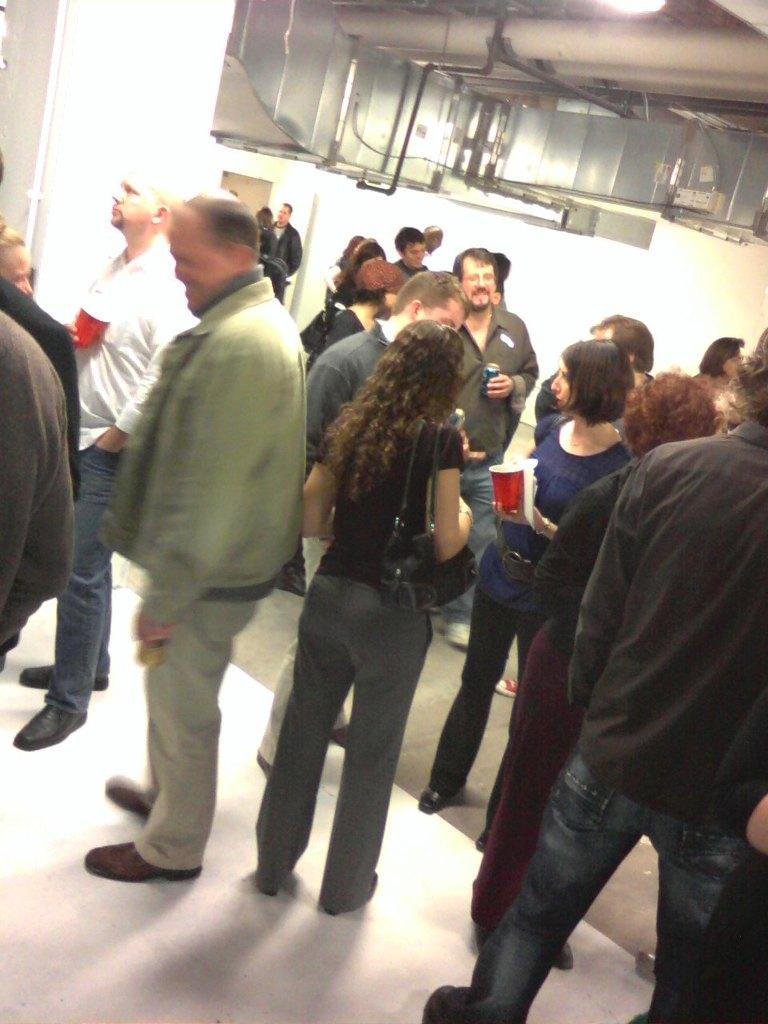What type of structure can be seen in the image? There is a pillar and a wall in the image. What else is present in the image besides the structures? There are objects and people in the image. What are some people doing in the image? Some people are standing, and some are holding objects. What can be seen at the bottom of the image? The floor is visible at the bottom portion of the image. What type of boats can be seen sailing in the image? There are no boats present in the image. What language are the people speaking in the image? There is no indication of the language being spoken in the image. 